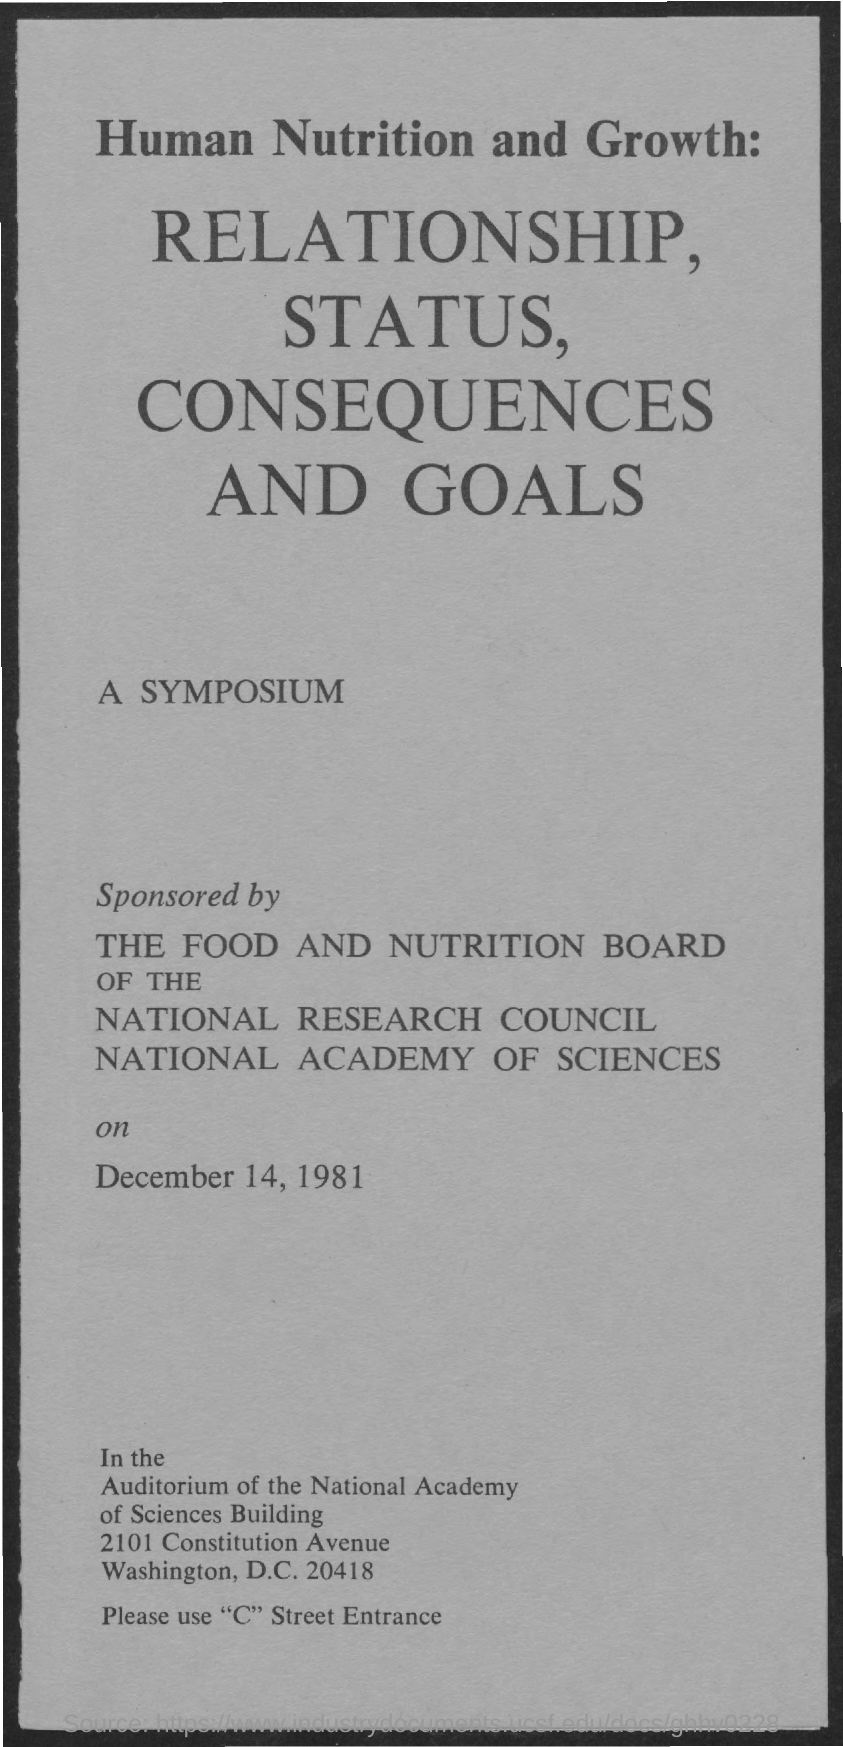What is the date on the document?
Provide a succinct answer. December 14, 1981. 